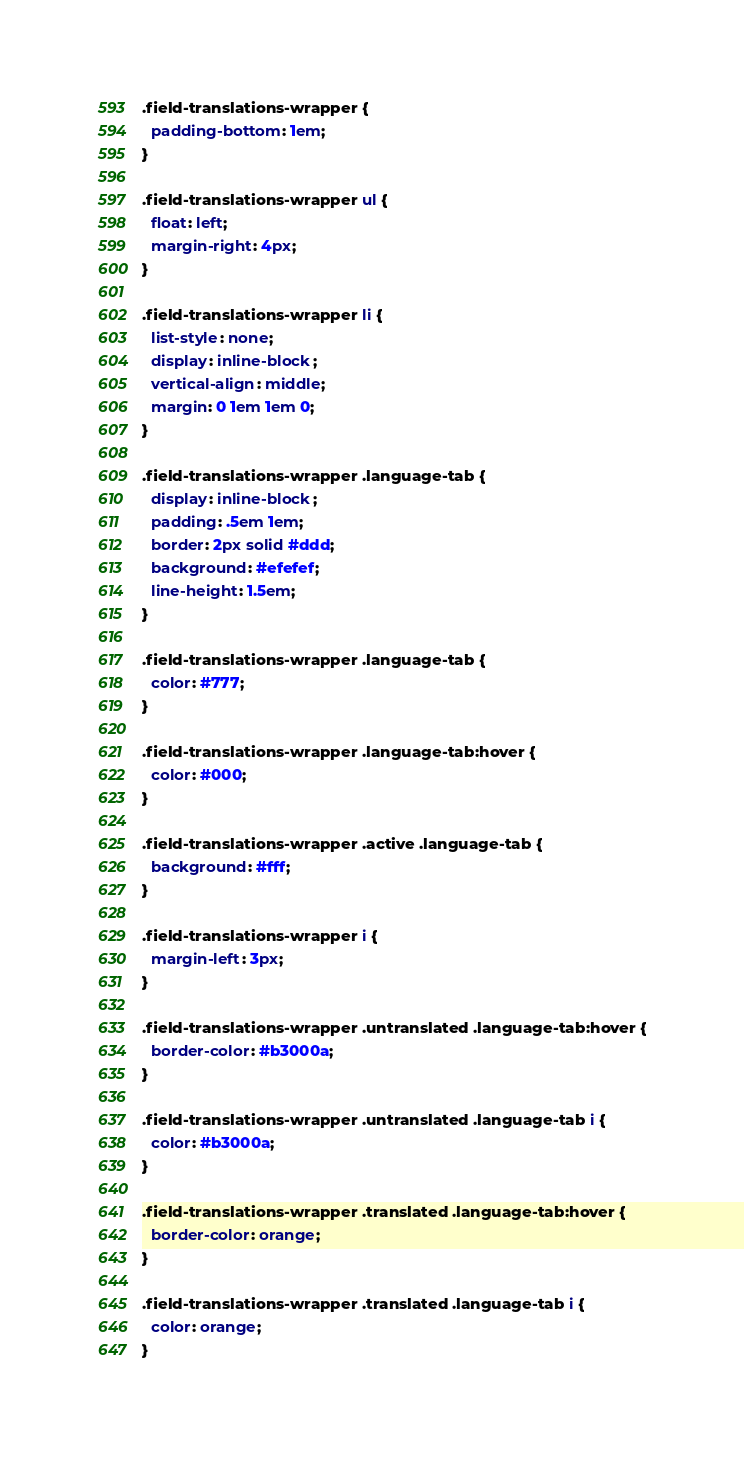Convert code to text. <code><loc_0><loc_0><loc_500><loc_500><_CSS_>.field-translations-wrapper {
  padding-bottom: 1em;
}

.field-translations-wrapper ul {
  float: left;
  margin-right: 4px;
}

.field-translations-wrapper li {
  list-style: none;
  display: inline-block;
  vertical-align: middle;
  margin: 0 1em 1em 0;
}

.field-translations-wrapper .language-tab {
  display: inline-block;
  padding: .5em 1em;
  border: 2px solid #ddd;
  background: #efefef;
  line-height: 1.5em;
}

.field-translations-wrapper .language-tab {
  color: #777;
}

.field-translations-wrapper .language-tab:hover {
  color: #000;
}

.field-translations-wrapper .active .language-tab {
  background: #fff;
}

.field-translations-wrapper i {
  margin-left: 3px;
}

.field-translations-wrapper .untranslated .language-tab:hover {
  border-color: #b3000a;
}

.field-translations-wrapper .untranslated .language-tab i {
  color: #b3000a;
}

.field-translations-wrapper .translated .language-tab:hover {
  border-color: orange;
}

.field-translations-wrapper .translated .language-tab i {
  color: orange;
}

</code> 